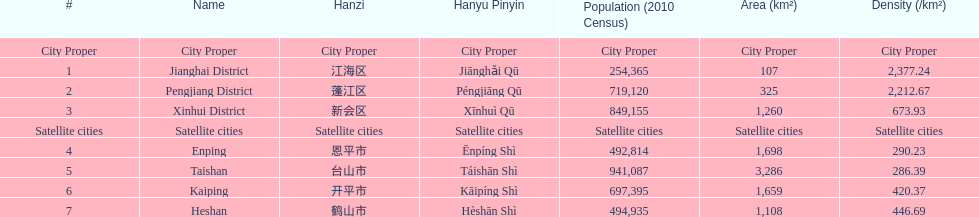Is the population density in enping greater/smaller than in kaiping? Less. 